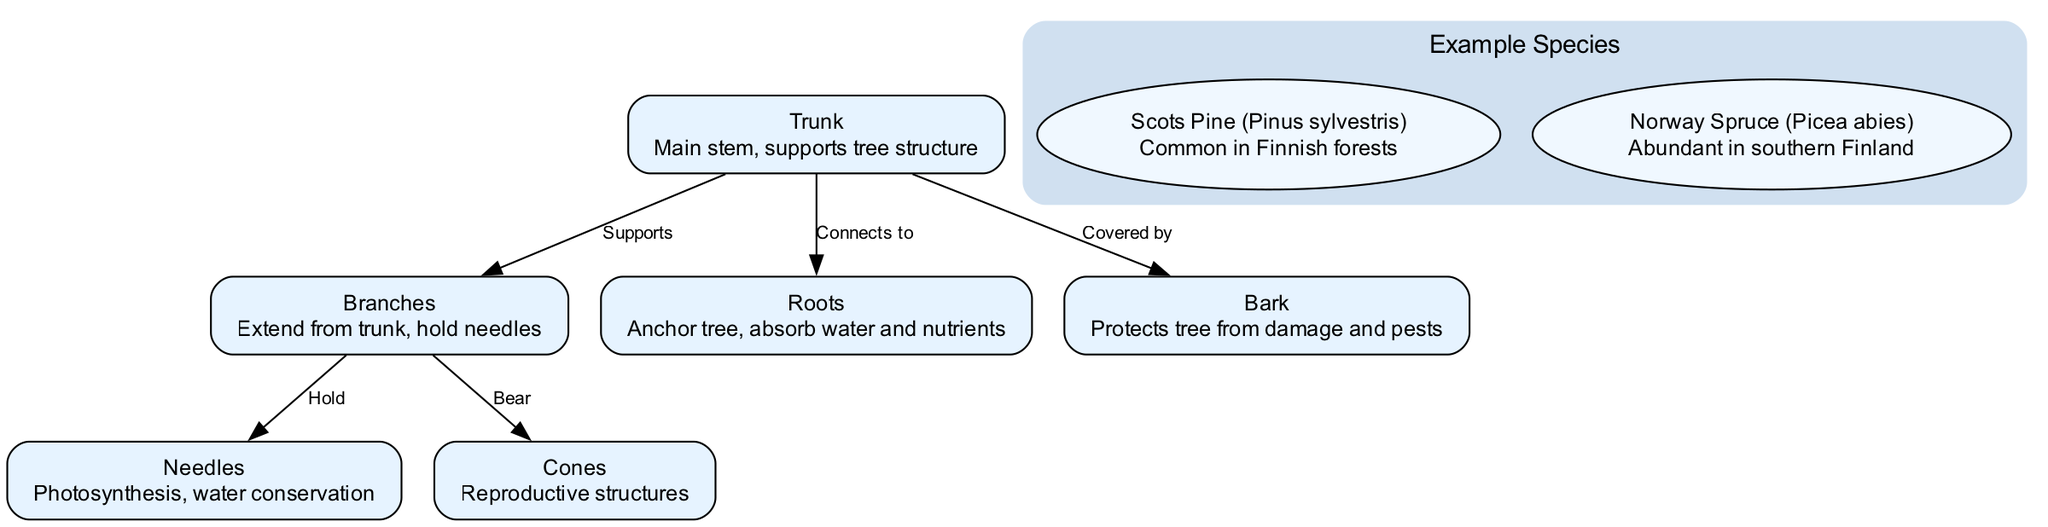What is the main stem of a coniferous tree called? The diagram identifies "Trunk" as the main stem of the tree, providing support for the entire structure.
Answer: Trunk How many main nodes are shown in the diagram? By counting the nodes listed in the diagram, we find that there are a total of six main nodes.
Answer: Six What do branches connect to in a coniferous tree? According to the diagram, branches extend from the trunk and hold the needles and bear the cones, thus they connect to both of these structures.
Answer: Needles and cones What is the function of needles in a coniferous tree? The diagram specifies that needles play a role in photosynthesis and water conservation for the coniferous tree.
Answer: Photosynthesis and water conservation Which structure protects the tree from damage and pests? The diagram clearly labels "Bark" as the outer layer providing protection against external threats.
Answer: Bark What does the trunk connect to in a coniferous tree? The connections shown in the diagram reveal that the trunk connects to both the roots and the bark, indicating relationships with these structures.
Answer: Roots and bark What are the reproductive structures of a coniferous tree? The diagram identifies "Cones" as the reproductive structures, indicating their importance in reproduction for these trees.
Answer: Cones Which coniferous tree species is common in Finnish forests? The diagram lists "Scots Pine (Pinus sylvestris)" as a common species found in Finnish forests.
Answer: Scots Pine What do roots do in a coniferous tree? The diagram states that roots anchor the tree while also absorbing water and nutrients, indicating their crucial role in sustenance.
Answer: Anchor and absorb water and nutrients 